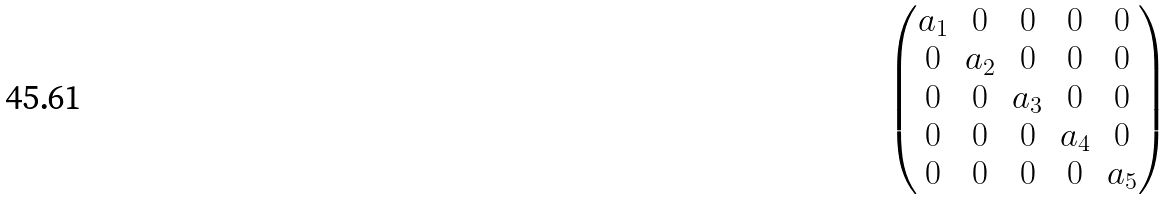<formula> <loc_0><loc_0><loc_500><loc_500>\begin{pmatrix} a _ { 1 } & 0 & 0 & 0 & 0 \\ 0 & a _ { 2 } & 0 & 0 & 0 \\ 0 & 0 & a _ { 3 } & 0 & 0 \\ 0 & 0 & 0 & a _ { 4 } & 0 \\ 0 & 0 & 0 & 0 & a _ { 5 } \\ \end{pmatrix}</formula> 